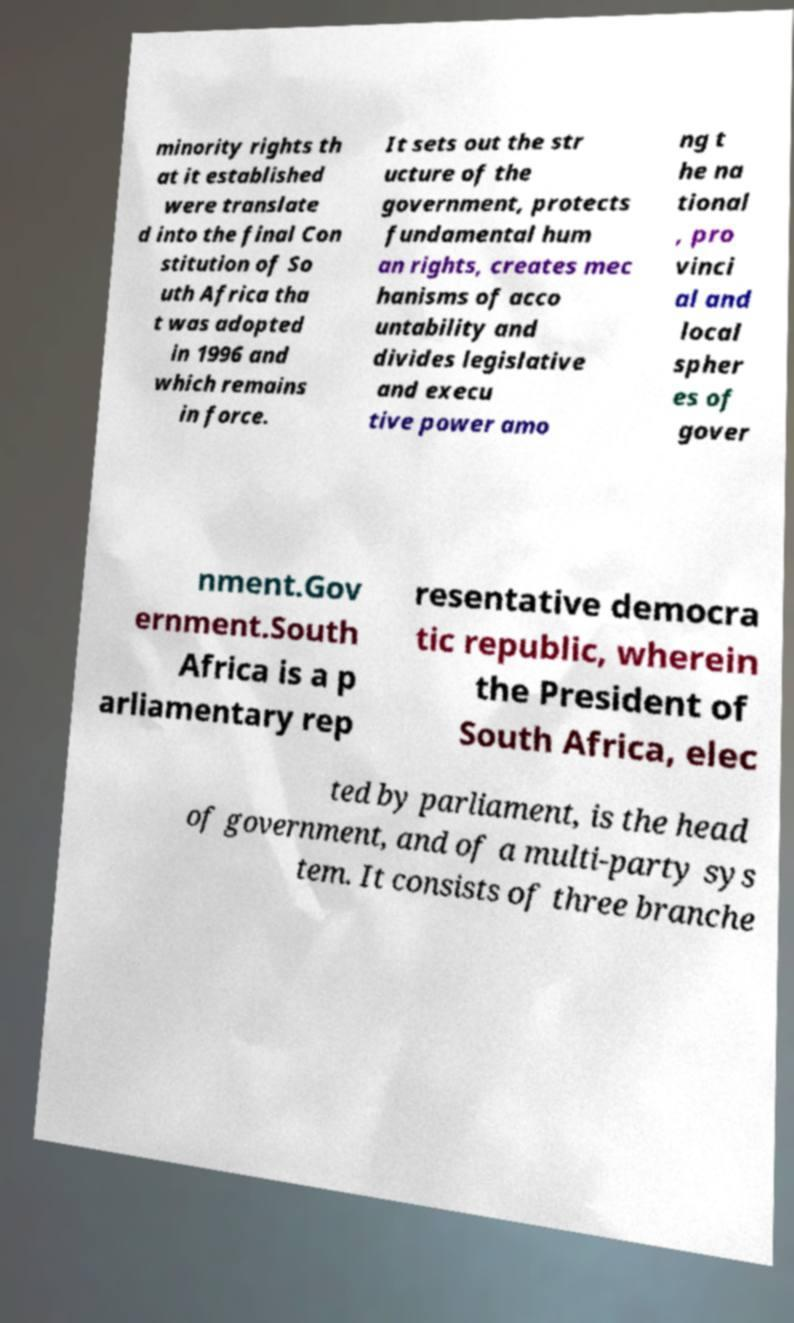What messages or text are displayed in this image? I need them in a readable, typed format. minority rights th at it established were translate d into the final Con stitution of So uth Africa tha t was adopted in 1996 and which remains in force. It sets out the str ucture of the government, protects fundamental hum an rights, creates mec hanisms of acco untability and divides legislative and execu tive power amo ng t he na tional , pro vinci al and local spher es of gover nment.Gov ernment.South Africa is a p arliamentary rep resentative democra tic republic, wherein the President of South Africa, elec ted by parliament, is the head of government, and of a multi-party sys tem. It consists of three branche 